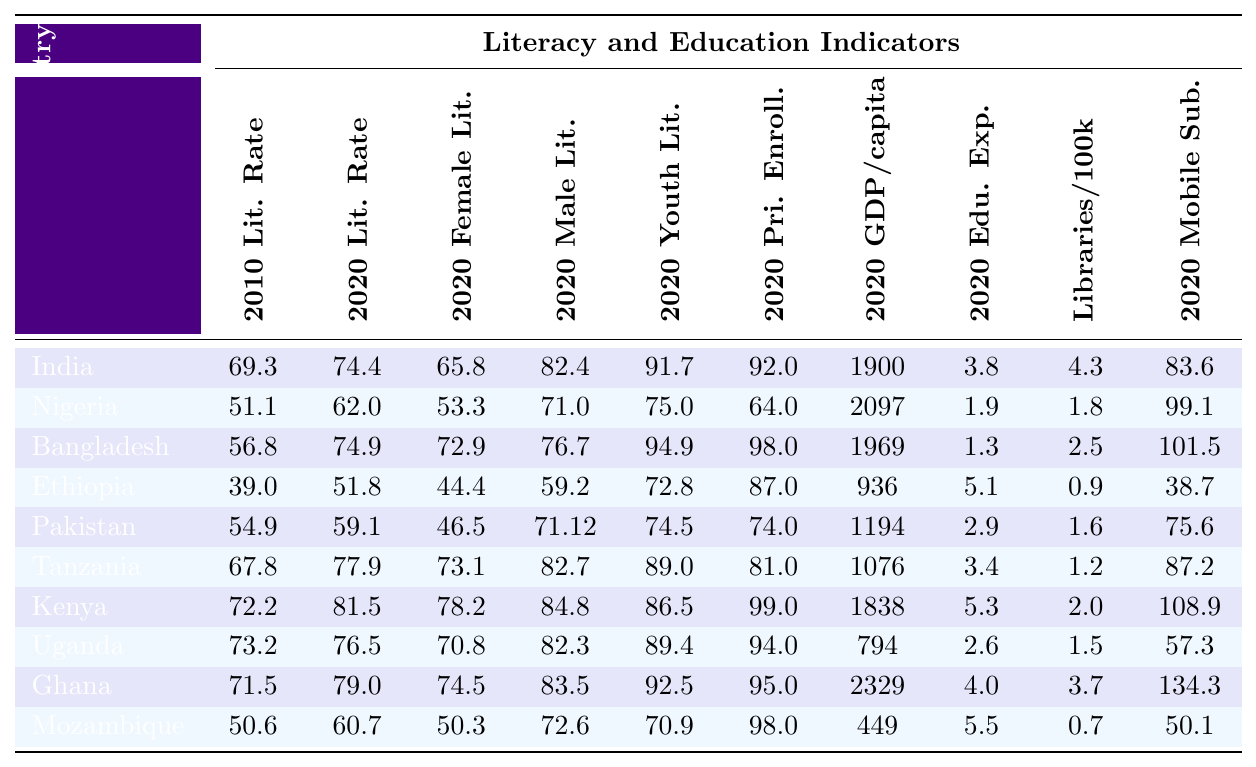What is the literacy rate of India in 2020? Referring to the table, the literacy rate of India in 2020 is noted in the column labeled "2020 Lit. Rate." That value is 74.4.
Answer: 74.4 Which country had the highest female literacy rate in 2020? By examining the "2020 Female Lit." column, Kenya has the highest female literacy rate at 78.2.
Answer: Kenya What was the change in literacy rate for Nigeria from 2010 to 2020? The literacy rate for Nigeria in 2010 was 51.1 and in 2020 it was 62.0. The change is calculated as 62.0 - 51.1 = 10.9.
Answer: 10.9 Which country has the lowest GDP per capita in 2020? Looking at the "2020 GDP/capita" column, Mozambique has the lowest GDP per capita at 449.
Answer: Mozambique Is the primary school enrollment rate in Uganda higher than in Tanzania in 2020? Uganda's primary school enrollment rate is 94.0 while Tanzania's is 81.0. Since 94.0 > 81.0, the statement is true.
Answer: Yes Calculate the average literacy rate of the countries listed in 2020. Summing the values in the "2020 Lit. Rate" column gives: 74.4 + 62.0 + 74.9 + 51.8 + 59.1 + 77.9 + 81.5 + 76.5 + 79.0 + 60.7 = 679.4. There are 10 countries, so the average is 679.4 / 10 = 67.94.
Answer: 67.94 How many countries had a literacy rate of 70 or above in 2020? Referring to the "2020 Lit. Rate" column, India, Bangladesh, Kenya, Uganda, Ghana, and Tanzania had rates of 70 or above. Counting these gives 6 countries.
Answer: 6 Which country shows the greatest increase in literacy rate from 2010 to 2020? Calculating the increase for each country by subtracting the 2010 literacy rate from the 2020 literacy rate shows that India increased by 5.1, Nigeria by 10.9, Bangladesh by 18.1, Ethiopia by 12.8, Pakistan by 4.2, Tanzania by 10.1, Kenya by 9.3, Uganda by 3.3, Ghana by 7.5, and Mozambique by 10.1. Bangladesh shows the highest increase of 18.1.
Answer: Bangladesh Does Nigeria have a higher youth literacy rate than Ethiopia in 2020? Comparing the youth literacy rates in the "2020 Youth Lit." column, Nigeria has 75.0 while Ethiopia has 72.8. Since 75.0 > 72.8, the statement is true.
Answer: Yes What is the ratio of mobile phone subscriptions per 100 people between Ghana and Mozambique in 2020? The mobile phone subscriptions for Ghana is 134.3 and for Mozambique is 50.1. The ratio is calculated as 134.3 / 50.1 ≈ 2.68.
Answer: 2.68 